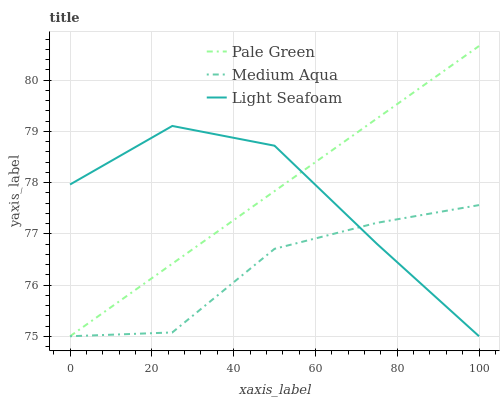Does Medium Aqua have the minimum area under the curve?
Answer yes or no. Yes. Does Pale Green have the maximum area under the curve?
Answer yes or no. Yes. Does Light Seafoam have the minimum area under the curve?
Answer yes or no. No. Does Light Seafoam have the maximum area under the curve?
Answer yes or no. No. Is Pale Green the smoothest?
Answer yes or no. Yes. Is Light Seafoam the roughest?
Answer yes or no. Yes. Is Medium Aqua the smoothest?
Answer yes or no. No. Is Medium Aqua the roughest?
Answer yes or no. No. Does Pale Green have the highest value?
Answer yes or no. Yes. Does Light Seafoam have the highest value?
Answer yes or no. No. Does Medium Aqua intersect Light Seafoam?
Answer yes or no. Yes. Is Medium Aqua less than Light Seafoam?
Answer yes or no. No. Is Medium Aqua greater than Light Seafoam?
Answer yes or no. No. 